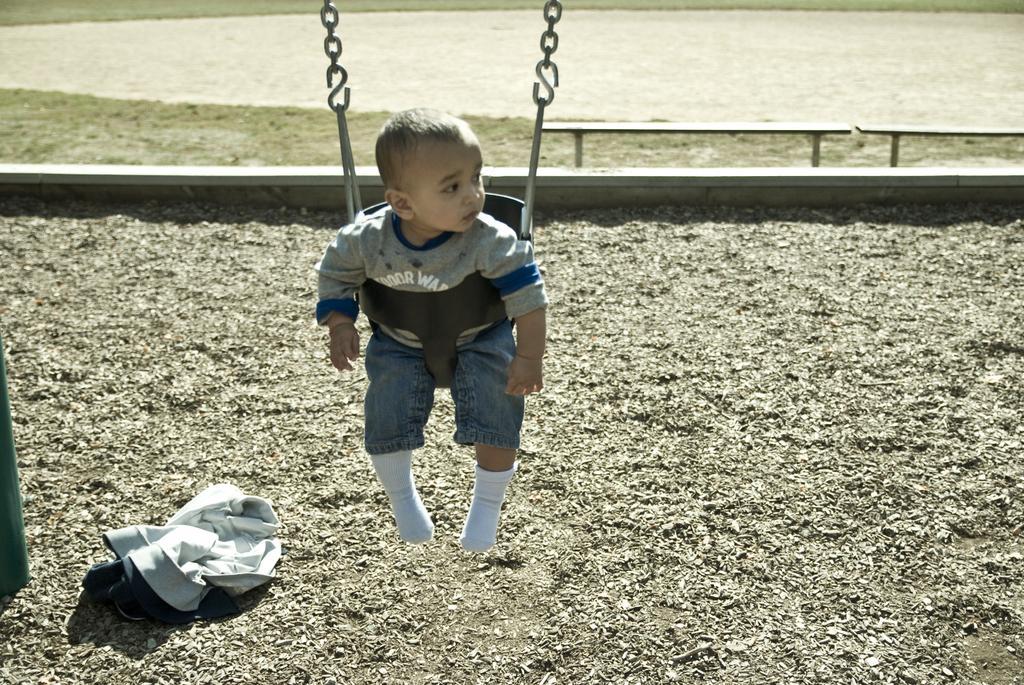Describe this image in one or two sentences. In this image we can see a kid sitting on the swing, there is a pole, benches, and a jacket on the ground. 